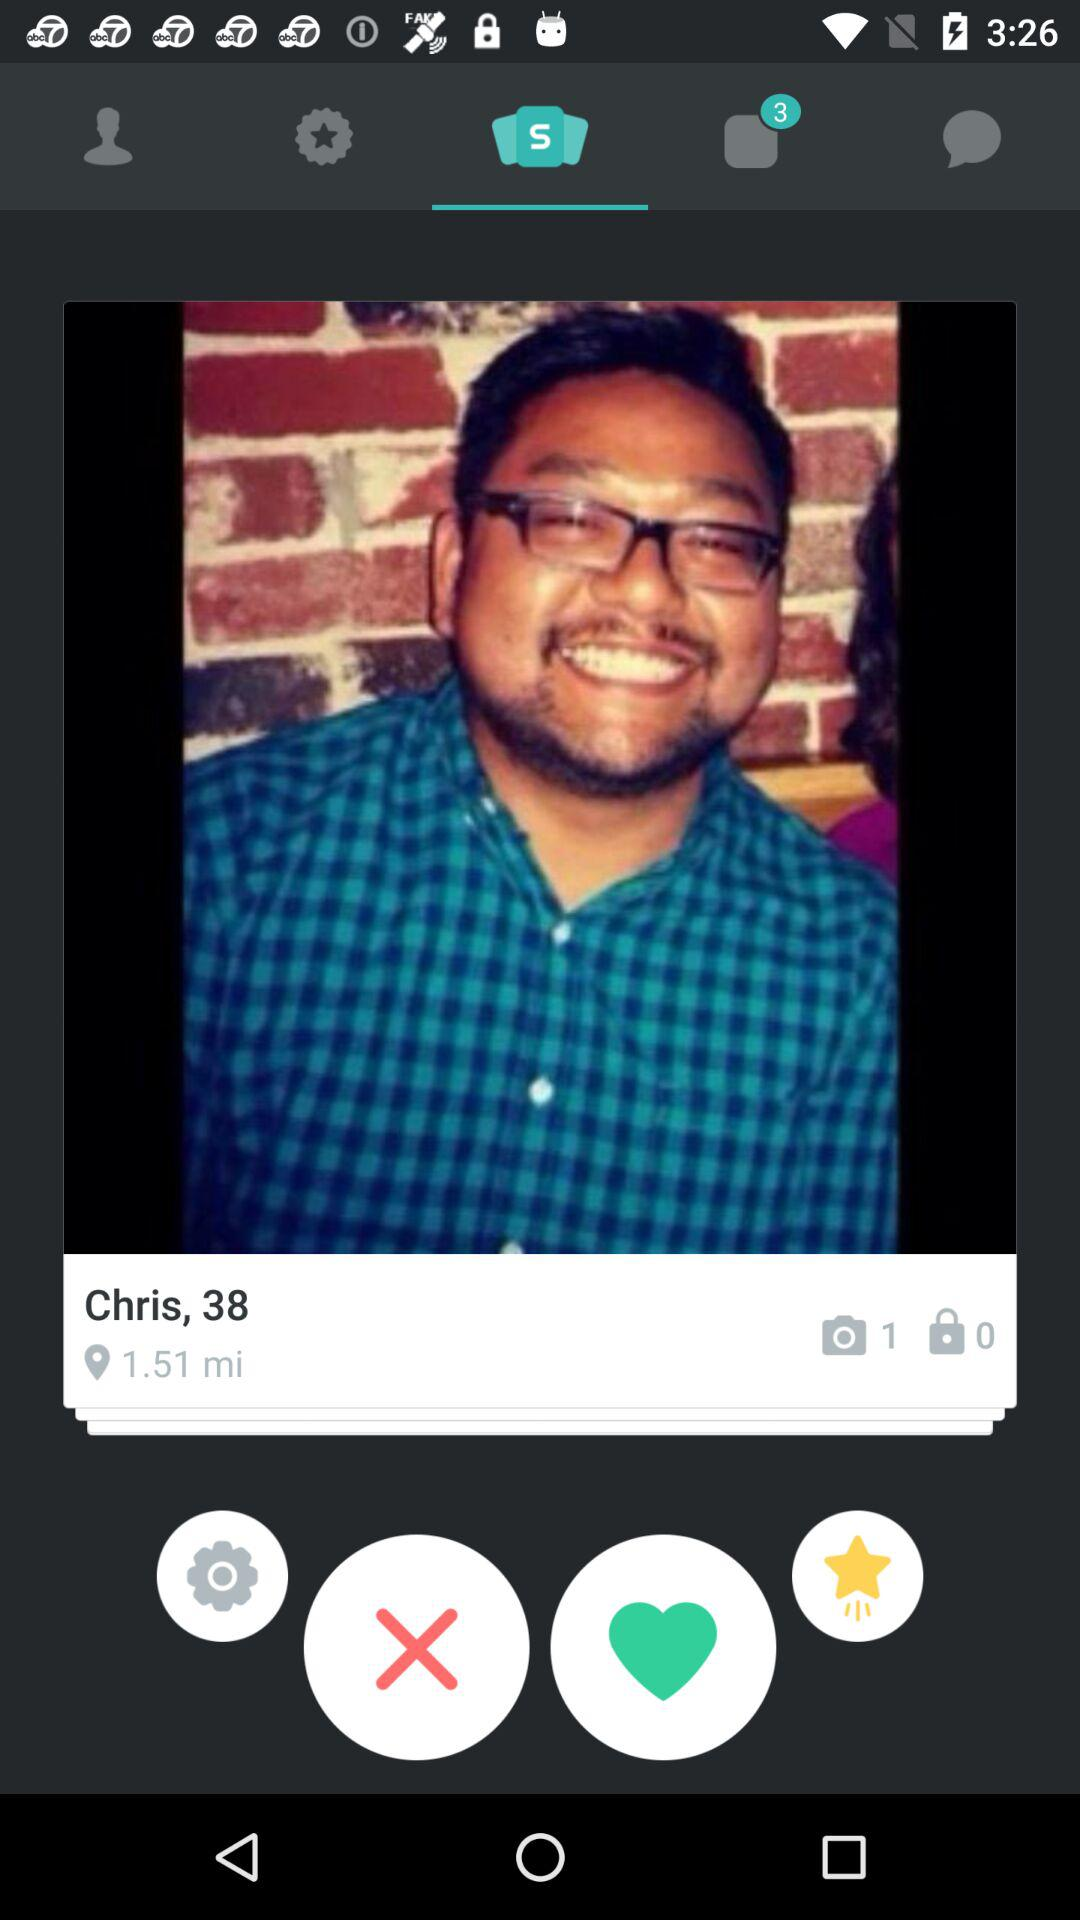What is the age of Chris? Chris's age is 38 years old. 